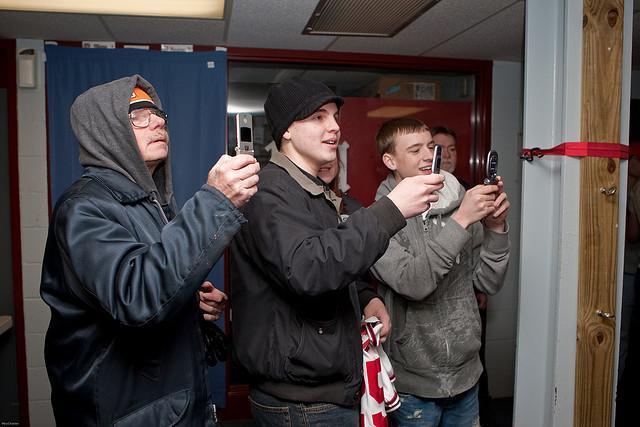How many people are shown?
Give a very brief answer. 5. How many people can you see?
Give a very brief answer. 3. 